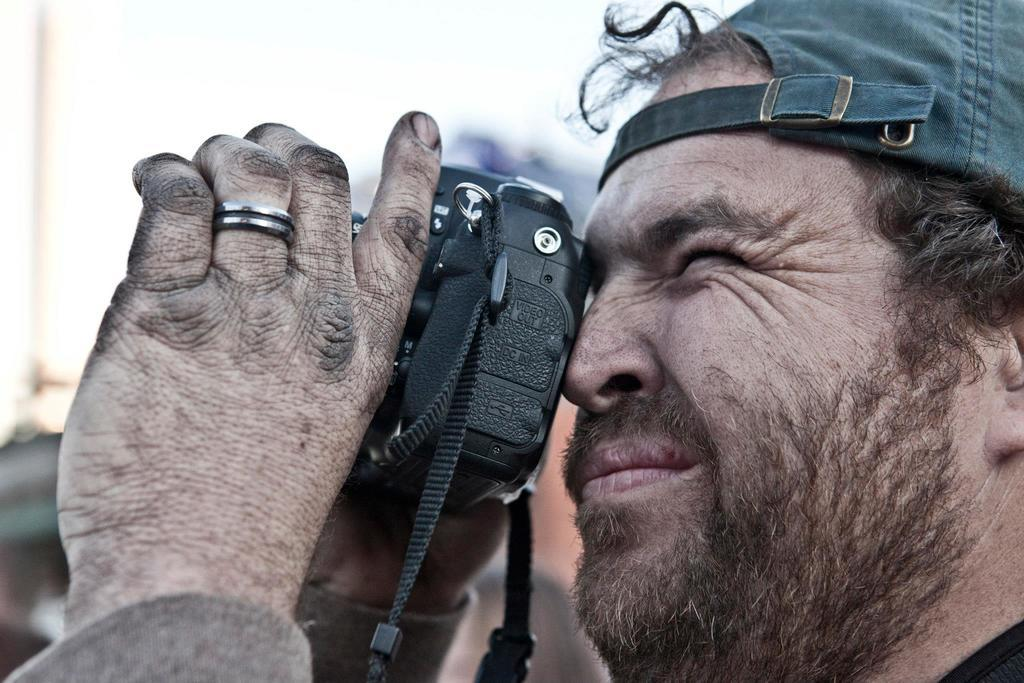What is the main subject of the image? There is a person in the image. What is the person doing in the image? The person is taking pictures. What object is the person holding in the image? The person is holding a camera. What type of headwear is the person wearing in the image? The person is wearing a cap on their head. What type of impulse can be seen affecting the person in the image? There is no mention of any impulse affecting the person in the image. Can you hear the person whistling in the image? There is no sound in the image, so it is impossible to hear the person whistling. 